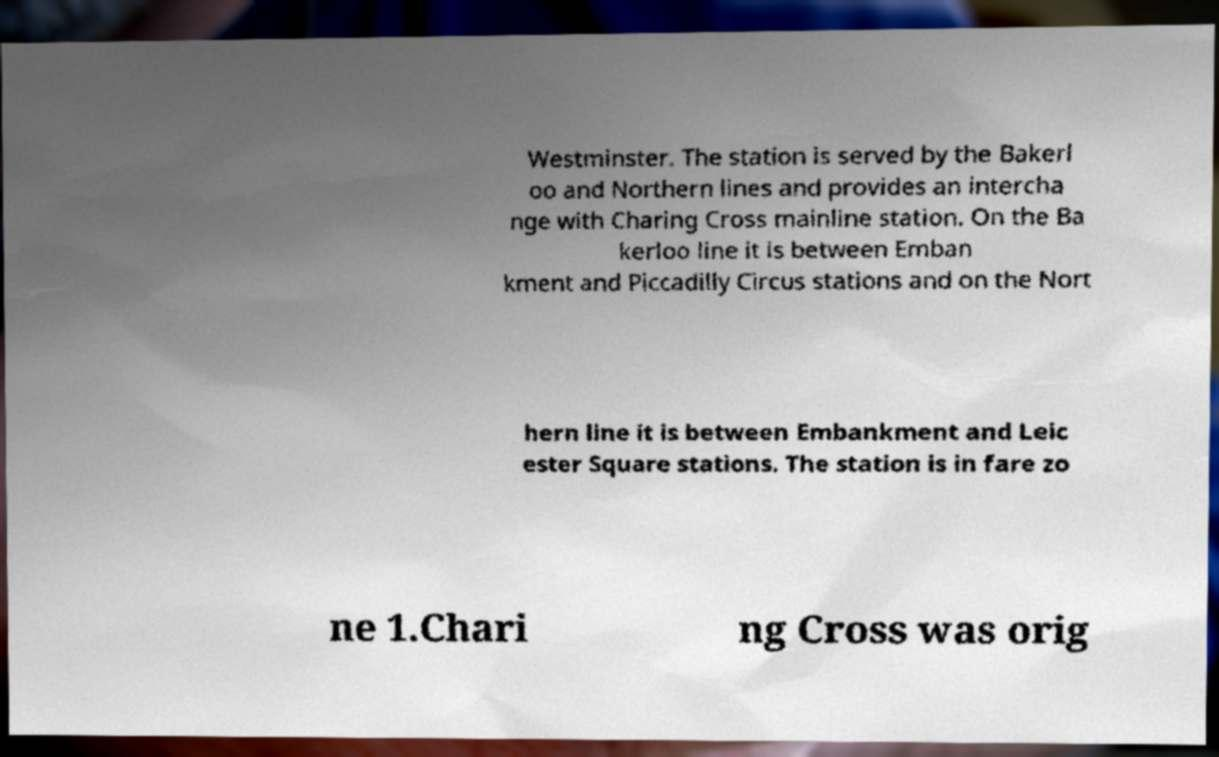Could you extract and type out the text from this image? Westminster. The station is served by the Bakerl oo and Northern lines and provides an intercha nge with Charing Cross mainline station. On the Ba kerloo line it is between Emban kment and Piccadilly Circus stations and on the Nort hern line it is between Embankment and Leic ester Square stations. The station is in fare zo ne 1.Chari ng Cross was orig 